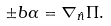Convert formula to latex. <formula><loc_0><loc_0><loc_500><loc_500>\pm b { \alpha } = \nabla _ { \hat { n } } \Pi .</formula> 